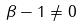Convert formula to latex. <formula><loc_0><loc_0><loc_500><loc_500>\beta - 1 \ne 0</formula> 